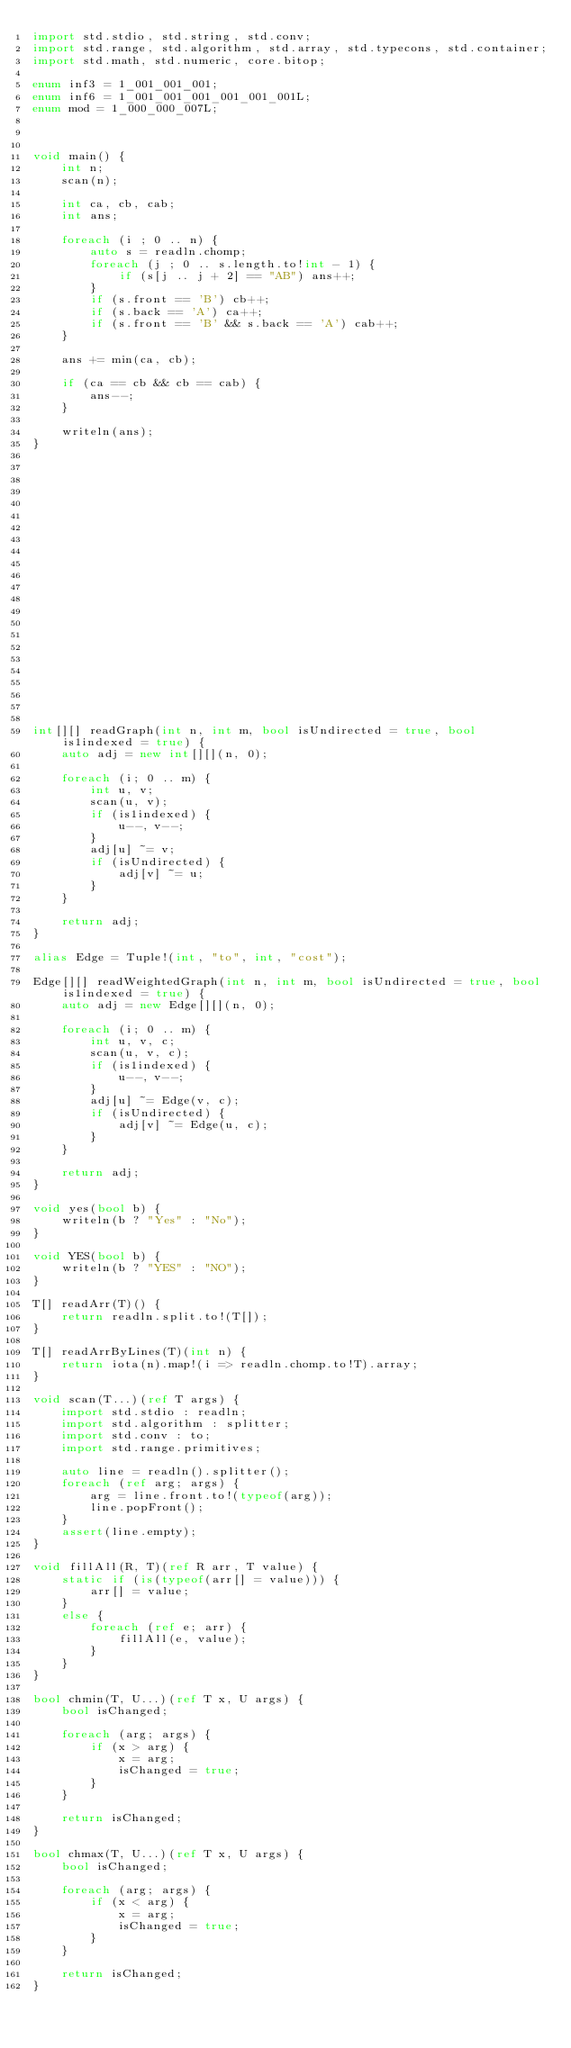<code> <loc_0><loc_0><loc_500><loc_500><_D_>import std.stdio, std.string, std.conv;
import std.range, std.algorithm, std.array, std.typecons, std.container;
import std.math, std.numeric, core.bitop;

enum inf3 = 1_001_001_001;
enum inf6 = 1_001_001_001_001_001_001L;
enum mod = 1_000_000_007L;



void main() {
    int n;
    scan(n);

    int ca, cb, cab;
    int ans;

    foreach (i ; 0 .. n) {
        auto s = readln.chomp;
        foreach (j ; 0 .. s.length.to!int - 1) {
            if (s[j .. j + 2] == "AB") ans++;
        }
        if (s.front == 'B') cb++;
        if (s.back == 'A') ca++;
        if (s.front == 'B' && s.back == 'A') cab++;
    }

    ans += min(ca, cb);

    if (ca == cb && cb == cab) {
        ans--;
    }

    writeln(ans);
}























int[][] readGraph(int n, int m, bool isUndirected = true, bool is1indexed = true) {
    auto adj = new int[][](n, 0);

    foreach (i; 0 .. m) {
        int u, v;
        scan(u, v);
        if (is1indexed) {
            u--, v--;
        }
        adj[u] ~= v;
        if (isUndirected) {
            adj[v] ~= u;
        }
    }

    return adj;
}

alias Edge = Tuple!(int, "to", int, "cost");

Edge[][] readWeightedGraph(int n, int m, bool isUndirected = true, bool is1indexed = true) {
    auto adj = new Edge[][](n, 0);

    foreach (i; 0 .. m) {
        int u, v, c;
        scan(u, v, c);
        if (is1indexed) {
            u--, v--;
        }
        adj[u] ~= Edge(v, c);
        if (isUndirected) {
            adj[v] ~= Edge(u, c);
        }
    }

    return adj;
}

void yes(bool b) {
    writeln(b ? "Yes" : "No");
}

void YES(bool b) {
    writeln(b ? "YES" : "NO");
}

T[] readArr(T)() {
    return readln.split.to!(T[]);
}

T[] readArrByLines(T)(int n) {
    return iota(n).map!(i => readln.chomp.to!T).array;
}

void scan(T...)(ref T args) {
    import std.stdio : readln;
    import std.algorithm : splitter;
    import std.conv : to;
    import std.range.primitives;

    auto line = readln().splitter();
    foreach (ref arg; args) {
        arg = line.front.to!(typeof(arg));
        line.popFront();
    }
    assert(line.empty);
}

void fillAll(R, T)(ref R arr, T value) {
    static if (is(typeof(arr[] = value))) {
        arr[] = value;
    }
    else {
        foreach (ref e; arr) {
            fillAll(e, value);
        }
    }
}

bool chmin(T, U...)(ref T x, U args) {
    bool isChanged;

    foreach (arg; args) {
        if (x > arg) {
            x = arg;
            isChanged = true;
        }
    }

    return isChanged;
}

bool chmax(T, U...)(ref T x, U args) {
    bool isChanged;

    foreach (arg; args) {
        if (x < arg) {
            x = arg;
            isChanged = true;
        }
    }

    return isChanged;
}
</code> 